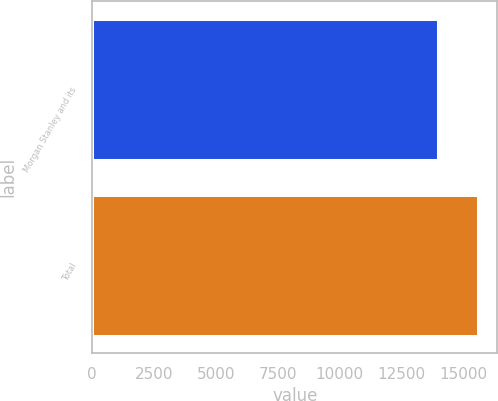Convert chart. <chart><loc_0><loc_0><loc_500><loc_500><bar_chart><fcel>Morgan Stanley and its<fcel>Total<nl><fcel>13971<fcel>15588<nl></chart> 